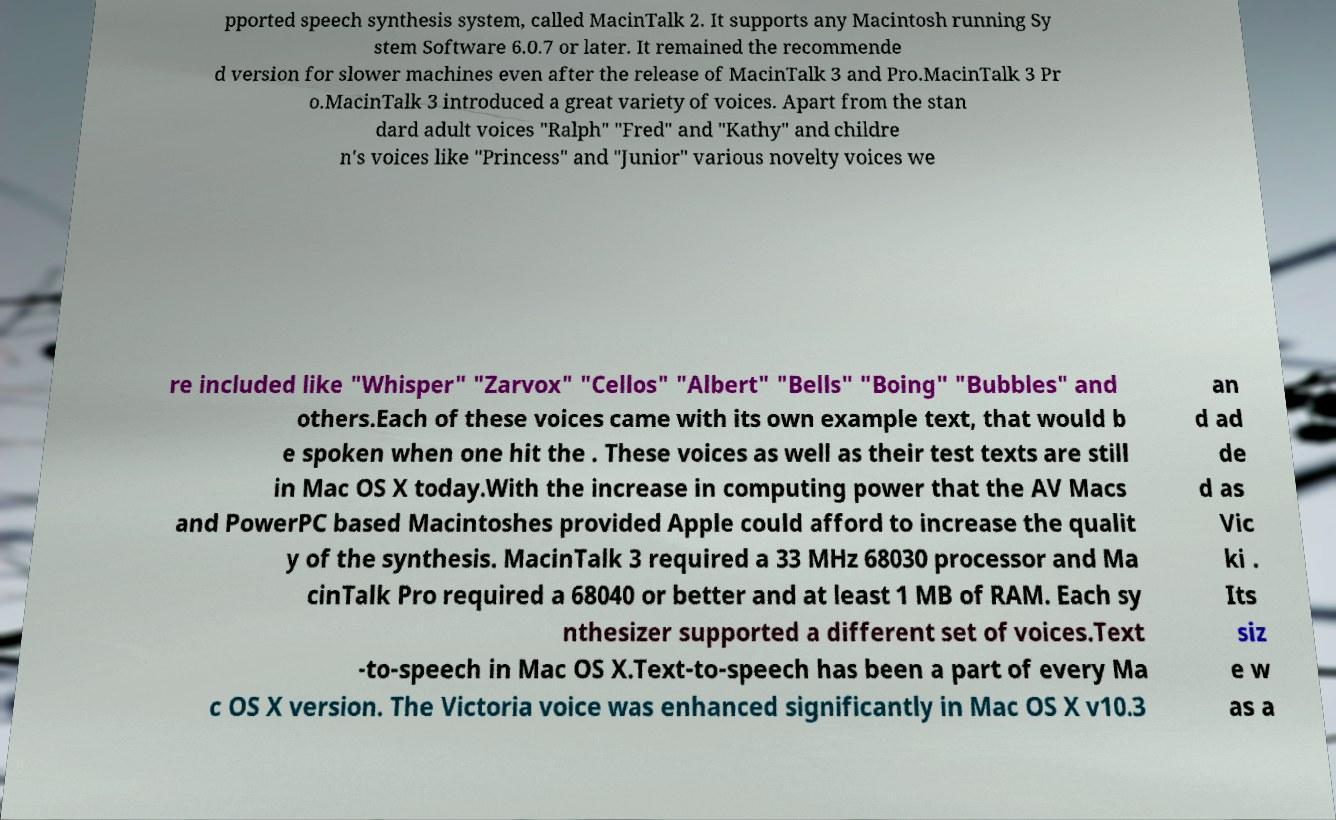Could you assist in decoding the text presented in this image and type it out clearly? pported speech synthesis system, called MacinTalk 2. It supports any Macintosh running Sy stem Software 6.0.7 or later. It remained the recommende d version for slower machines even after the release of MacinTalk 3 and Pro.MacinTalk 3 Pr o.MacinTalk 3 introduced a great variety of voices. Apart from the stan dard adult voices "Ralph" "Fred" and "Kathy" and childre n's voices like "Princess" and "Junior" various novelty voices we re included like "Whisper" "Zarvox" "Cellos" "Albert" "Bells" "Boing" "Bubbles" and others.Each of these voices came with its own example text, that would b e spoken when one hit the . These voices as well as their test texts are still in Mac OS X today.With the increase in computing power that the AV Macs and PowerPC based Macintoshes provided Apple could afford to increase the qualit y of the synthesis. MacinTalk 3 required a 33 MHz 68030 processor and Ma cinTalk Pro required a 68040 or better and at least 1 MB of RAM. Each sy nthesizer supported a different set of voices.Text -to-speech in Mac OS X.Text-to-speech has been a part of every Ma c OS X version. The Victoria voice was enhanced significantly in Mac OS X v10.3 an d ad de d as Vic ki . Its siz e w as a 